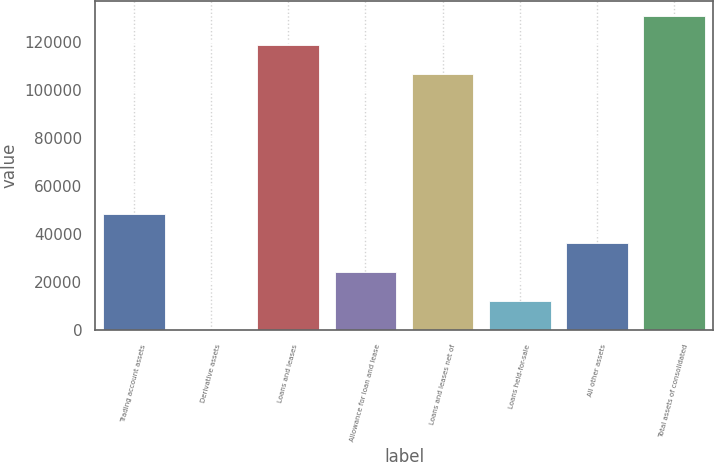Convert chart to OTSL. <chart><loc_0><loc_0><loc_500><loc_500><bar_chart><fcel>Trading account assets<fcel>Derivative assets<fcel>Loans and leases<fcel>Allowance for loan and lease<fcel>Loans and leases net of<fcel>Loans held-for-sale<fcel>All other assets<fcel>Total assets of consolidated<nl><fcel>48511.8<fcel>185<fcel>118526<fcel>24348.4<fcel>106444<fcel>12266.7<fcel>36430.1<fcel>130607<nl></chart> 